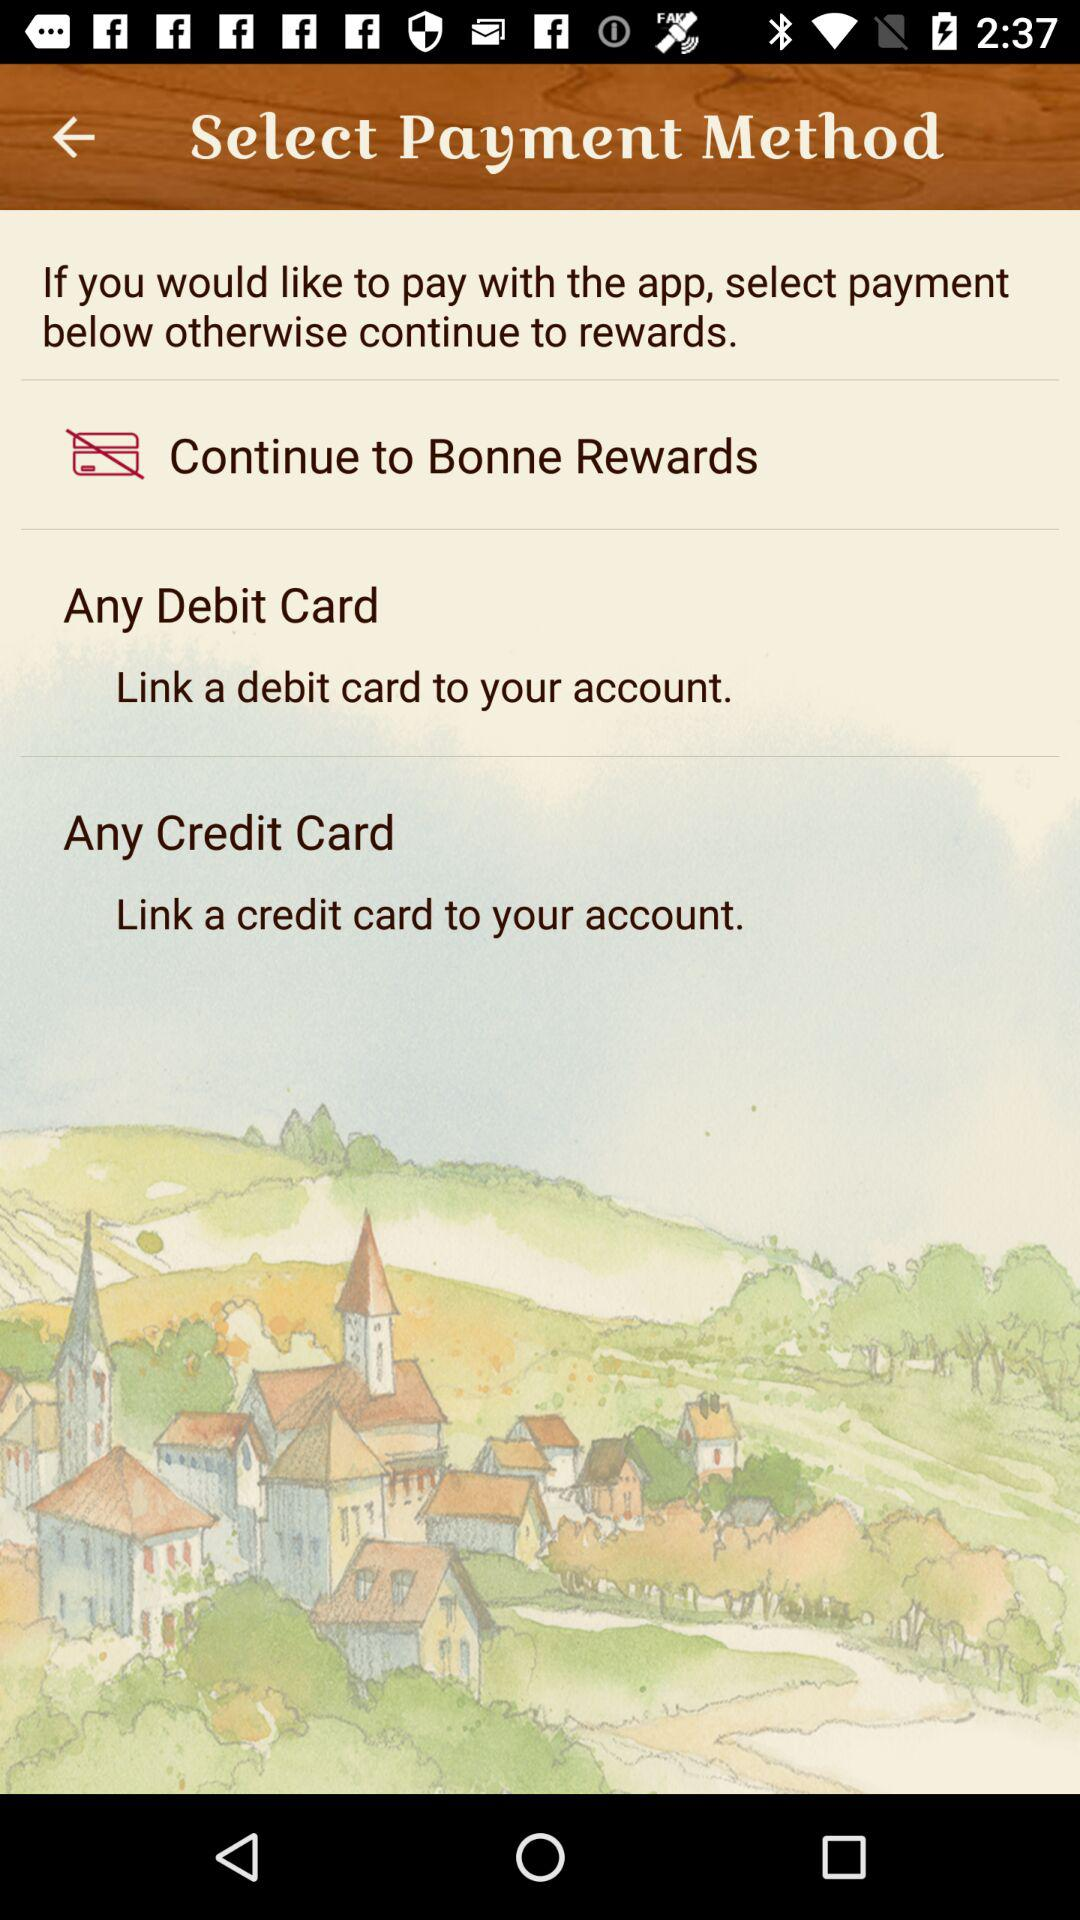How many payment methods are available?
Answer the question using a single word or phrase. 2 